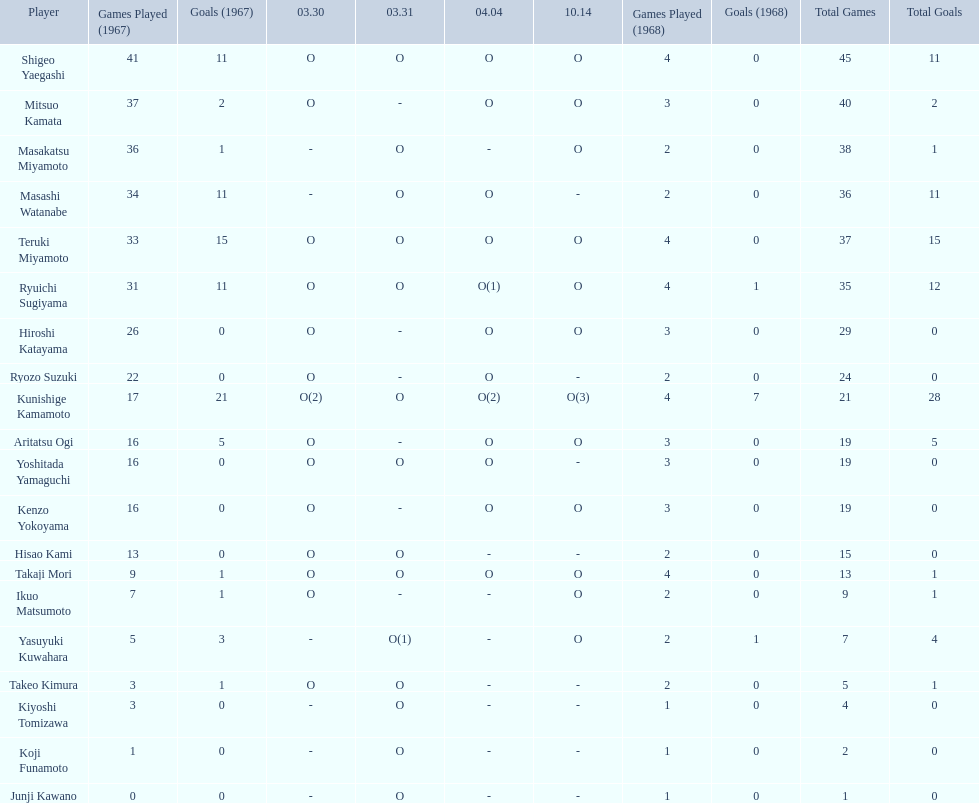Who are all of the players? Shigeo Yaegashi, Mitsuo Kamata, Masakatsu Miyamoto, Masashi Watanabe, Teruki Miyamoto, Ryuichi Sugiyama, Hiroshi Katayama, Ryozo Suzuki, Kunishige Kamamoto, Aritatsu Ogi, Yoshitada Yamaguchi, Kenzo Yokoyama, Hisao Kami, Takaji Mori, Ikuo Matsumoto, Yasuyuki Kuwahara, Takeo Kimura, Kiyoshi Tomizawa, Koji Funamoto, Junji Kawano. How many points did they receive? 45(11), 40(2), 38(1), 36(11), 37(15), 35(12), 29(0), 24(0), 21(28), 19(5), 19(0), 19(0), 15(0), 13(1), 9(1), 7(4), 5(1), 4(0), 2(0), 1(0). What about just takaji mori and junji kawano? 13(1), 1(0). Of the two, who had more points? Takaji Mori. 